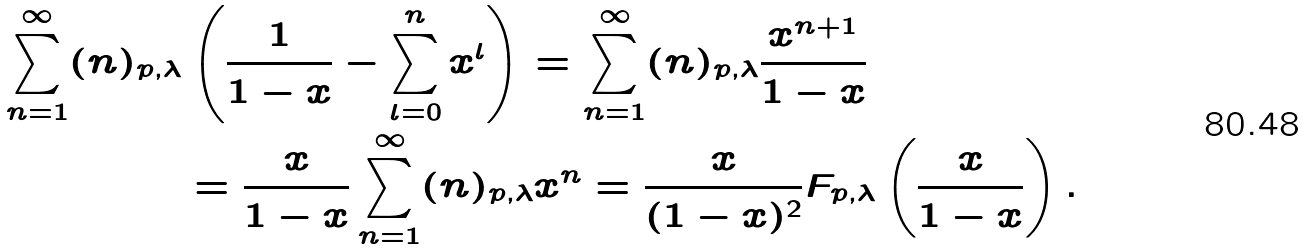<formula> <loc_0><loc_0><loc_500><loc_500>\sum _ { n = 1 } ^ { \infty } ( n ) _ { p , \lambda } & \left ( \frac { 1 } { 1 - x } - \sum _ { l = 0 } ^ { n } x ^ { l } \right ) = \sum _ { n = 1 } ^ { \infty } ( n ) _ { p , \lambda } \frac { x ^ { n + 1 } } { 1 - x } \\ & = \frac { x } { 1 - x } \sum _ { n = 1 } ^ { \infty } ( n ) _ { p , \lambda } x ^ { n } = \frac { x } { ( 1 - x ) ^ { 2 } } F _ { p , \lambda } \left ( \frac { x } { 1 - x } \right ) .</formula> 